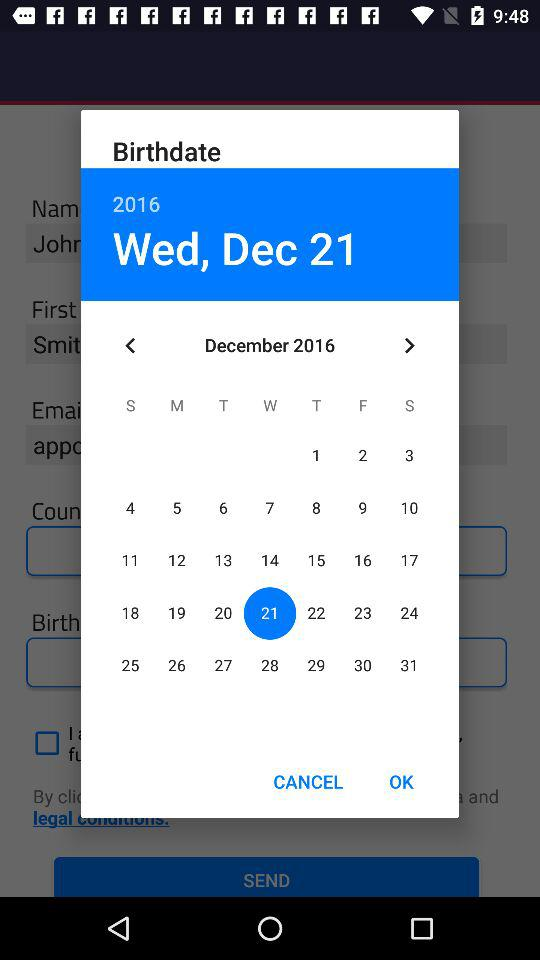Which date is selected? The selected date is Wednesday, December 21, 2016. 